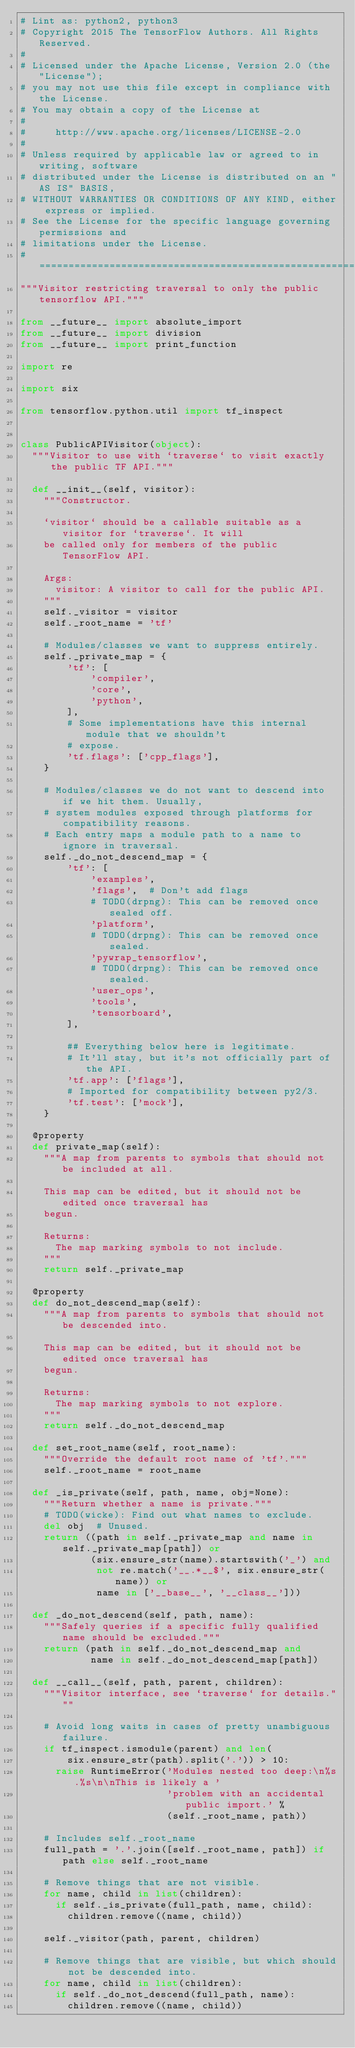<code> <loc_0><loc_0><loc_500><loc_500><_Python_># Lint as: python2, python3
# Copyright 2015 The TensorFlow Authors. All Rights Reserved.
#
# Licensed under the Apache License, Version 2.0 (the "License");
# you may not use this file except in compliance with the License.
# You may obtain a copy of the License at
#
#     http://www.apache.org/licenses/LICENSE-2.0
#
# Unless required by applicable law or agreed to in writing, software
# distributed under the License is distributed on an "AS IS" BASIS,
# WITHOUT WARRANTIES OR CONDITIONS OF ANY KIND, either express or implied.
# See the License for the specific language governing permissions and
# limitations under the License.
# ==============================================================================
"""Visitor restricting traversal to only the public tensorflow API."""

from __future__ import absolute_import
from __future__ import division
from __future__ import print_function

import re

import six

from tensorflow.python.util import tf_inspect


class PublicAPIVisitor(object):
  """Visitor to use with `traverse` to visit exactly the public TF API."""

  def __init__(self, visitor):
    """Constructor.

    `visitor` should be a callable suitable as a visitor for `traverse`. It will
    be called only for members of the public TensorFlow API.

    Args:
      visitor: A visitor to call for the public API.
    """
    self._visitor = visitor
    self._root_name = 'tf'

    # Modules/classes we want to suppress entirely.
    self._private_map = {
        'tf': [
            'compiler',
            'core',
            'python',
        ],
        # Some implementations have this internal module that we shouldn't
        # expose.
        'tf.flags': ['cpp_flags'],
    }

    # Modules/classes we do not want to descend into if we hit them. Usually,
    # system modules exposed through platforms for compatibility reasons.
    # Each entry maps a module path to a name to ignore in traversal.
    self._do_not_descend_map = {
        'tf': [
            'examples',
            'flags',  # Don't add flags
            # TODO(drpng): This can be removed once sealed off.
            'platform',
            # TODO(drpng): This can be removed once sealed.
            'pywrap_tensorflow',
            # TODO(drpng): This can be removed once sealed.
            'user_ops',
            'tools',
            'tensorboard',
        ],

        ## Everything below here is legitimate.
        # It'll stay, but it's not officially part of the API.
        'tf.app': ['flags'],
        # Imported for compatibility between py2/3.
        'tf.test': ['mock'],
    }

  @property
  def private_map(self):
    """A map from parents to symbols that should not be included at all.

    This map can be edited, but it should not be edited once traversal has
    begun.

    Returns:
      The map marking symbols to not include.
    """
    return self._private_map

  @property
  def do_not_descend_map(self):
    """A map from parents to symbols that should not be descended into.

    This map can be edited, but it should not be edited once traversal has
    begun.

    Returns:
      The map marking symbols to not explore.
    """
    return self._do_not_descend_map

  def set_root_name(self, root_name):
    """Override the default root name of 'tf'."""
    self._root_name = root_name

  def _is_private(self, path, name, obj=None):
    """Return whether a name is private."""
    # TODO(wicke): Find out what names to exclude.
    del obj  # Unused.
    return ((path in self._private_map and name in self._private_map[path]) or
            (six.ensure_str(name).startswith('_') and
             not re.match('__.*__$', six.ensure_str(name)) or
             name in ['__base__', '__class__']))

  def _do_not_descend(self, path, name):
    """Safely queries if a specific fully qualified name should be excluded."""
    return (path in self._do_not_descend_map and
            name in self._do_not_descend_map[path])

  def __call__(self, path, parent, children):
    """Visitor interface, see `traverse` for details."""

    # Avoid long waits in cases of pretty unambiguous failure.
    if tf_inspect.ismodule(parent) and len(
        six.ensure_str(path).split('.')) > 10:
      raise RuntimeError('Modules nested too deep:\n%s.%s\n\nThis is likely a '
                         'problem with an accidental public import.' %
                         (self._root_name, path))

    # Includes self._root_name
    full_path = '.'.join([self._root_name, path]) if path else self._root_name

    # Remove things that are not visible.
    for name, child in list(children):
      if self._is_private(full_path, name, child):
        children.remove((name, child))

    self._visitor(path, parent, children)

    # Remove things that are visible, but which should not be descended into.
    for name, child in list(children):
      if self._do_not_descend(full_path, name):
        children.remove((name, child))
</code> 